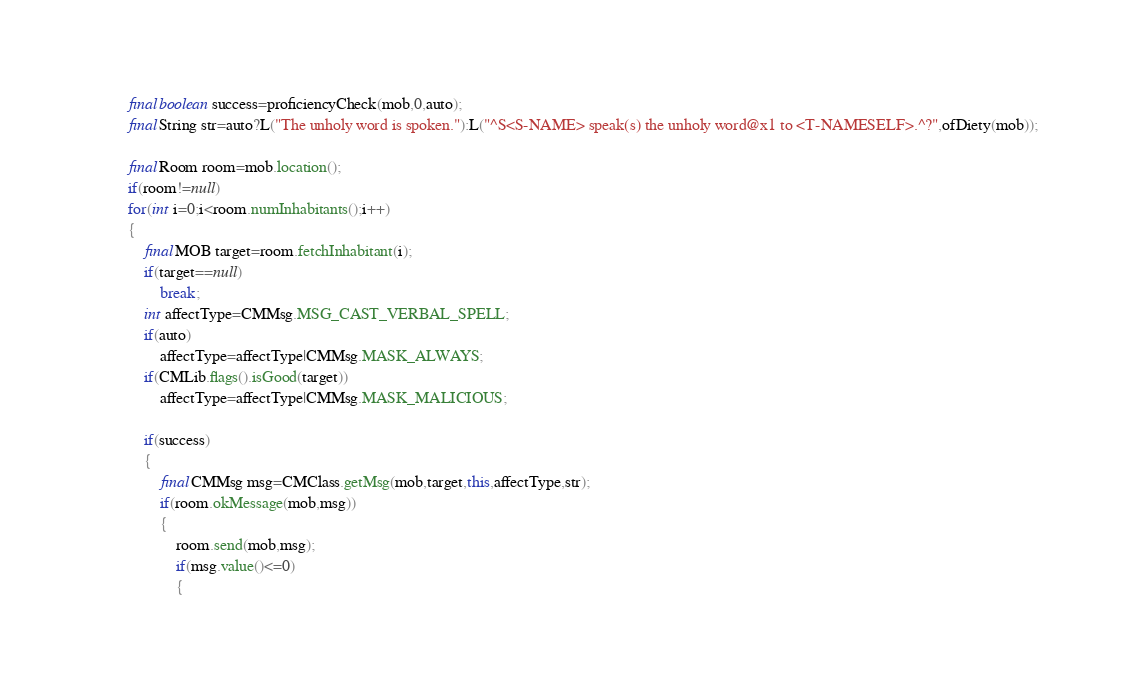<code> <loc_0><loc_0><loc_500><loc_500><_Java_>
		final boolean success=proficiencyCheck(mob,0,auto);
		final String str=auto?L("The unholy word is spoken."):L("^S<S-NAME> speak(s) the unholy word@x1 to <T-NAMESELF>.^?",ofDiety(mob));

		final Room room=mob.location();
		if(room!=null)
		for(int i=0;i<room.numInhabitants();i++)
		{
			final MOB target=room.fetchInhabitant(i);
			if(target==null)
				break;
			int affectType=CMMsg.MSG_CAST_VERBAL_SPELL;
			if(auto)
				affectType=affectType|CMMsg.MASK_ALWAYS;
			if(CMLib.flags().isGood(target))
				affectType=affectType|CMMsg.MASK_MALICIOUS;

			if(success)
			{
				final CMMsg msg=CMClass.getMsg(mob,target,this,affectType,str);
				if(room.okMessage(mob,msg))
				{
					room.send(mob,msg);
					if(msg.value()<=0)
					{</code> 